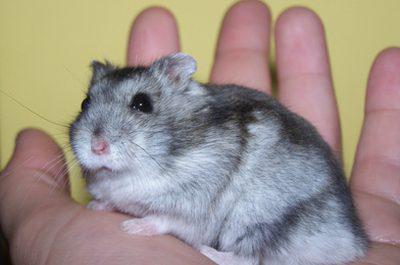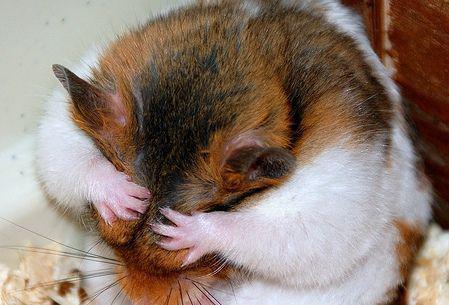The first image is the image on the left, the second image is the image on the right. Evaluate the accuracy of this statement regarding the images: "In one image the hamster is held in someone's hand and in the other the hamster is standing on sawdust.". Is it true? Answer yes or no. Yes. The first image is the image on the left, the second image is the image on the right. For the images shown, is this caption "A hamster is being held in someone's hand." true? Answer yes or no. Yes. 